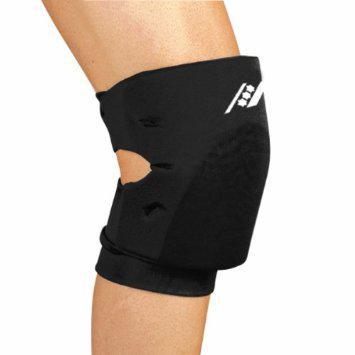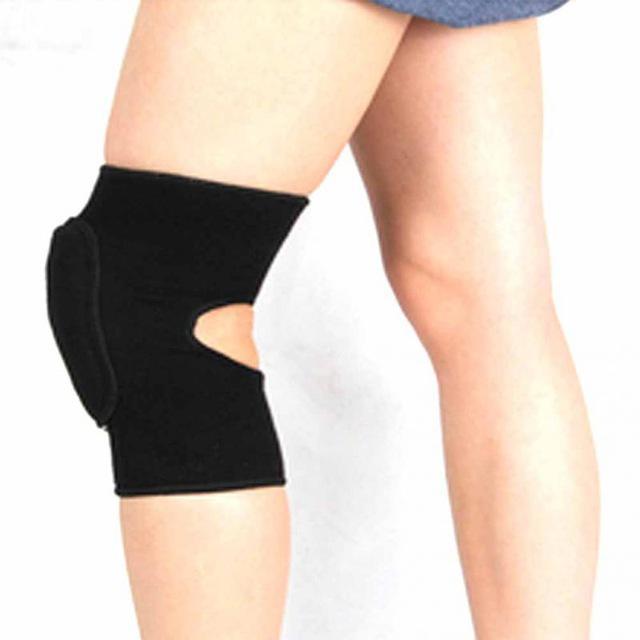The first image is the image on the left, the second image is the image on the right. Examine the images to the left and right. Is the description "Only black kneepads are shown, and the left and right images contain the same number of kneepads." accurate? Answer yes or no. Yes. 